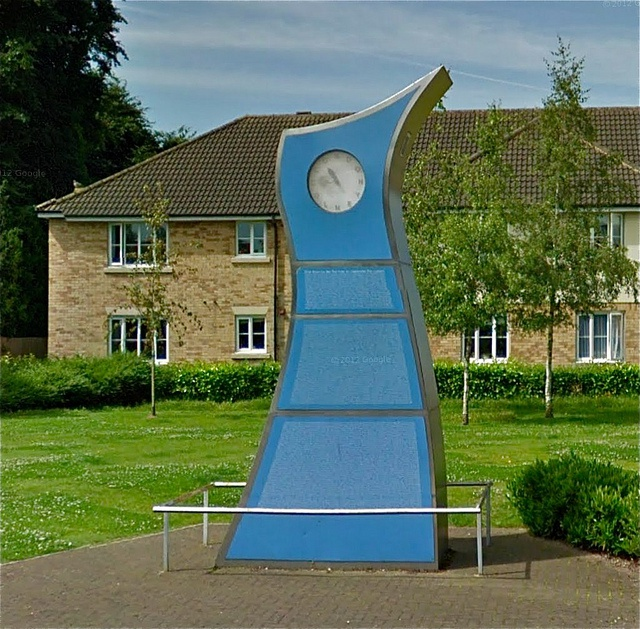Describe the objects in this image and their specific colors. I can see a clock in black, darkgray, gray, and blue tones in this image. 